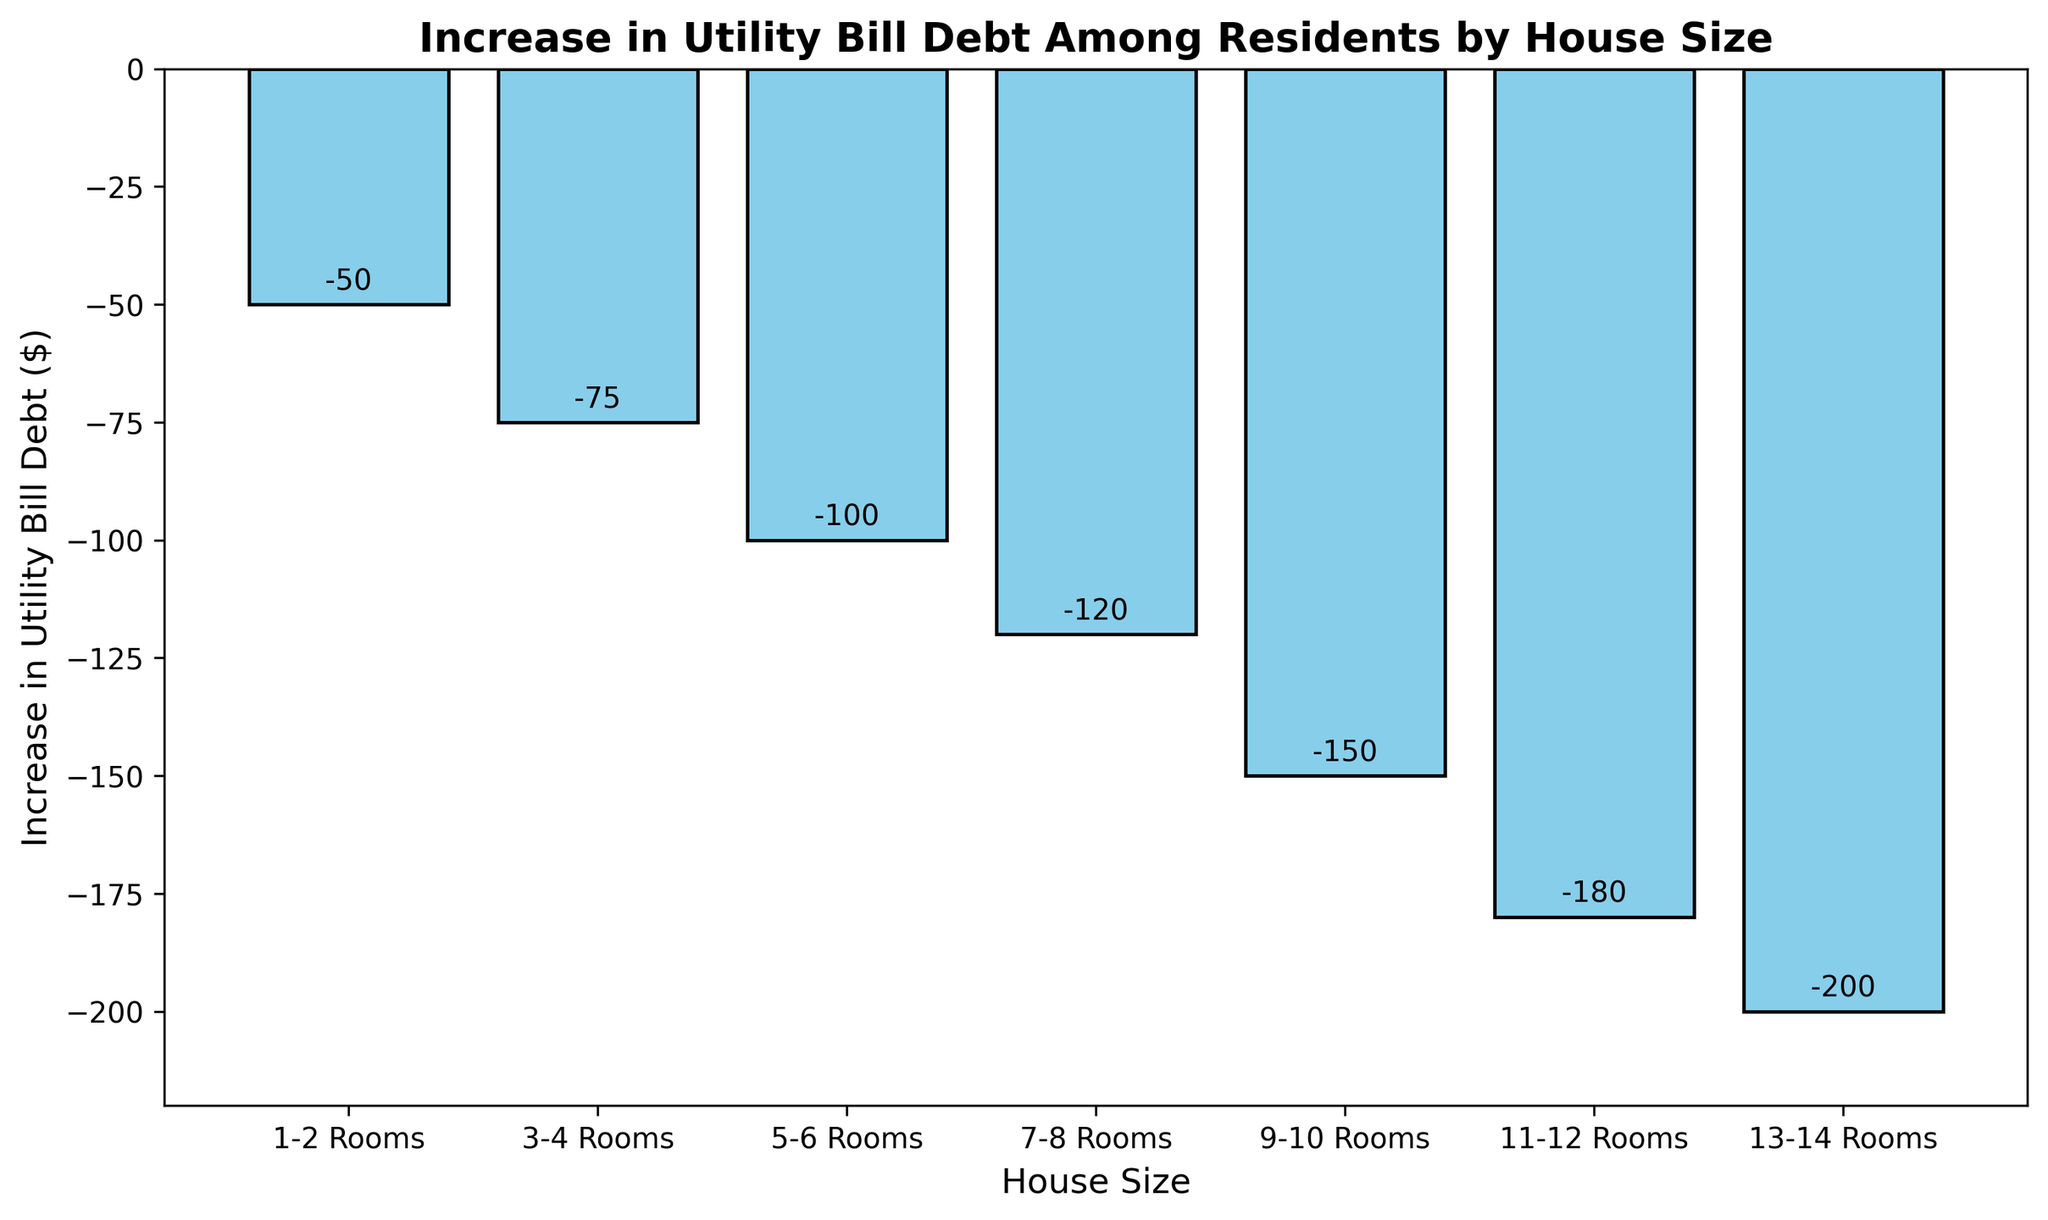Which house size group shows the highest increase in utility bill debt? The bar representing the '13-14 Rooms' house size group is the lowest, indicating the highest increase in utility bill debt at -$200.
Answer: 13-14 Rooms How much more is the increase in utility bill debt for houses with 7-8 rooms compared to those with 1-2 rooms? The increase in debt for houses with 7-8 rooms is -$120 and for 1-2 rooms is -$50. The difference is -$120 - (-$50) = -$70.
Answer: $70 What's the average increase in utility bill debt across all house sizes? Summing up all the increases: -$50 + -$75 + -$100 + -$120 + -$150 + -$180 + -$200 = -$875. Dividing by the number of house size groups (7), the average is -$875 / 7 = -$125.
Answer: $125 Which house size has the exact middle value of increase in utility bill debt among all listed sizes? The median house size group falls in the middle of the ordered list. The middle value for 7 groups is the 4th, '7-8 Rooms' with -$120.
Answer: 7-8 Rooms Compare the increase in utility bill debt for houses with 3-4 rooms and 11-12 rooms. Which one is higher? By how much? The increase in debt for 3-4 rooms is -$75, and for 11-12 rooms it is -$180. The difference is -$180 - (-$75) = -$105. The 11-12 rooms group has a higher increase in debt by $105.
Answer: 11-12 Rooms, $105 What visual attribute is used to indicate the increase in utility bill debt across different house sizes? The height of the bars is used to indicate the increase in utility bill debt, with lower bars indicating higher debt.
Answer: Height of bars Which house size group has the smallest increase in utility bill debt? The highest bar representing the '1-2 Rooms' house size group shows the smallest increase in utility bill debt of -$50.
Answer: 1-2 Rooms What's the combined increase in utility bill debt for house sizes 3-4 rooms and 5-6 rooms? The increase in debt for 3-4 rooms is -$75, and for 5-6 rooms it is -$100. The combined increase is -$75 + -$100 = -$175.
Answer: $175 Is the increase in utility bill debt steadily increasing with house sizes? The bars visibly decrease in height consistently as house size increases, showing a steady increase in debt.
Answer: Yes 